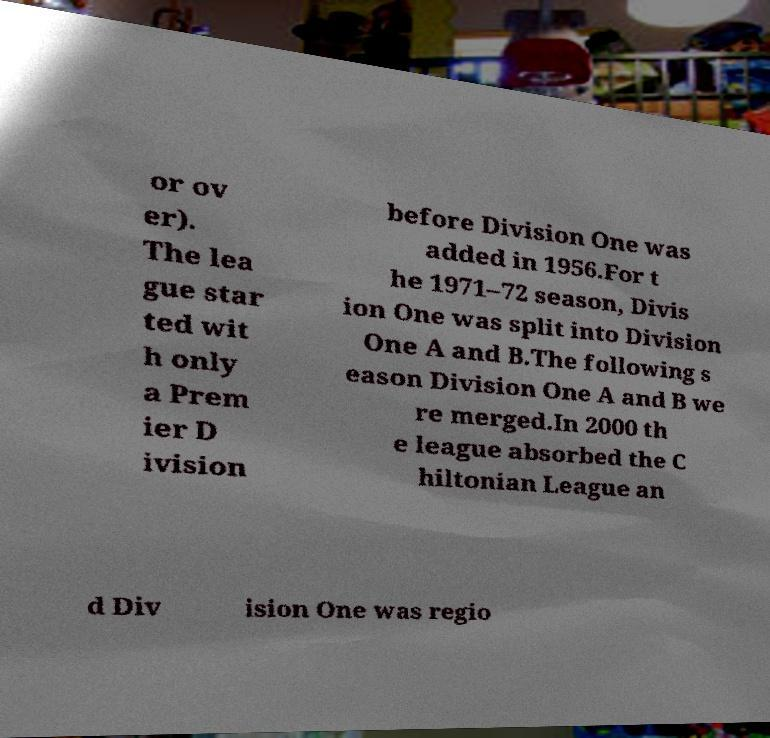There's text embedded in this image that I need extracted. Can you transcribe it verbatim? or ov er). The lea gue star ted wit h only a Prem ier D ivision before Division One was added in 1956.For t he 1971–72 season, Divis ion One was split into Division One A and B.The following s eason Division One A and B we re merged.In 2000 th e league absorbed the C hiltonian League an d Div ision One was regio 